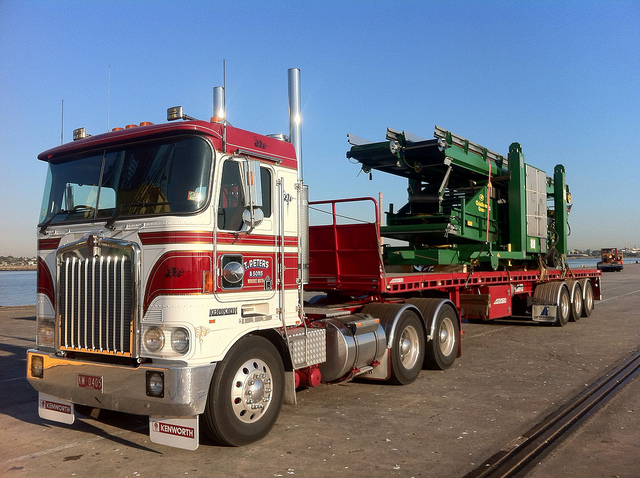Extract all visible text content from this image. KENWCRTH 